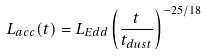<formula> <loc_0><loc_0><loc_500><loc_500>L _ { a c c } ( t ) = L _ { E d d } \left ( \frac { t } { t _ { d u s t } } \right ) ^ { - 2 5 / 1 8 } \,</formula> 